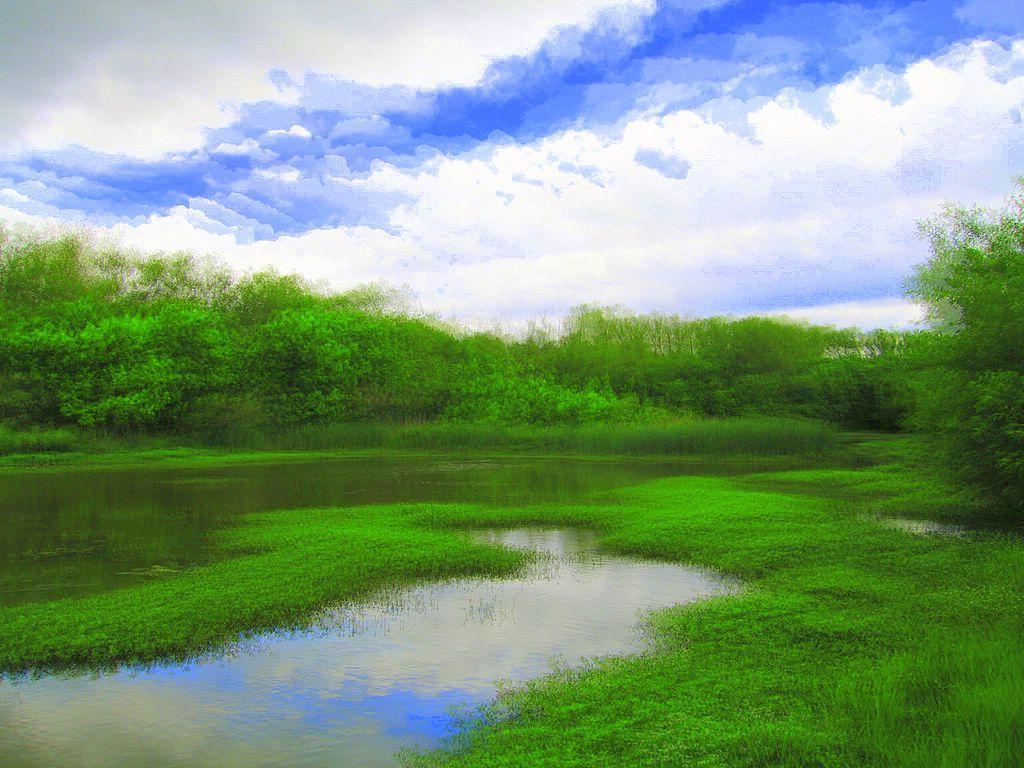What can be seen in the background of the image? The sky is visible in the image. What is the condition of the sky in the image? There are clouds in the sky. What type of vegetation is present in the image? There are trees and grass in the image. What body of water can be seen in the image? There is a lake in the image. What type of berry is growing on the trees in the image? There are no berries mentioned or visible in the image; the trees are not specified as fruit-bearing trees. 